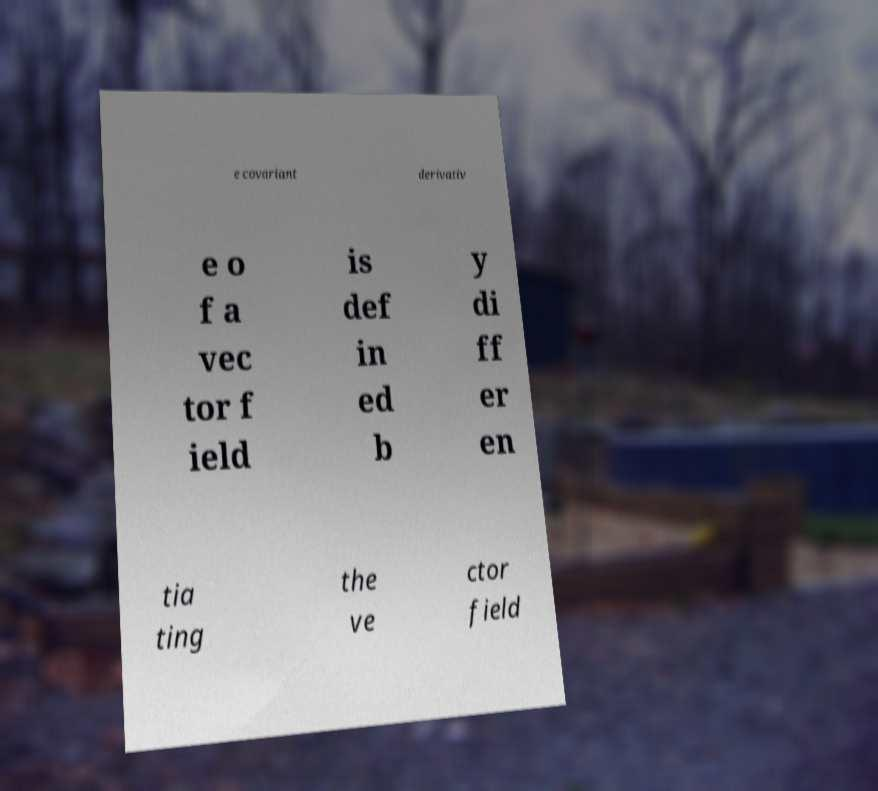Can you read and provide the text displayed in the image?This photo seems to have some interesting text. Can you extract and type it out for me? e covariant derivativ e o f a vec tor f ield is def in ed b y di ff er en tia ting the ve ctor field 